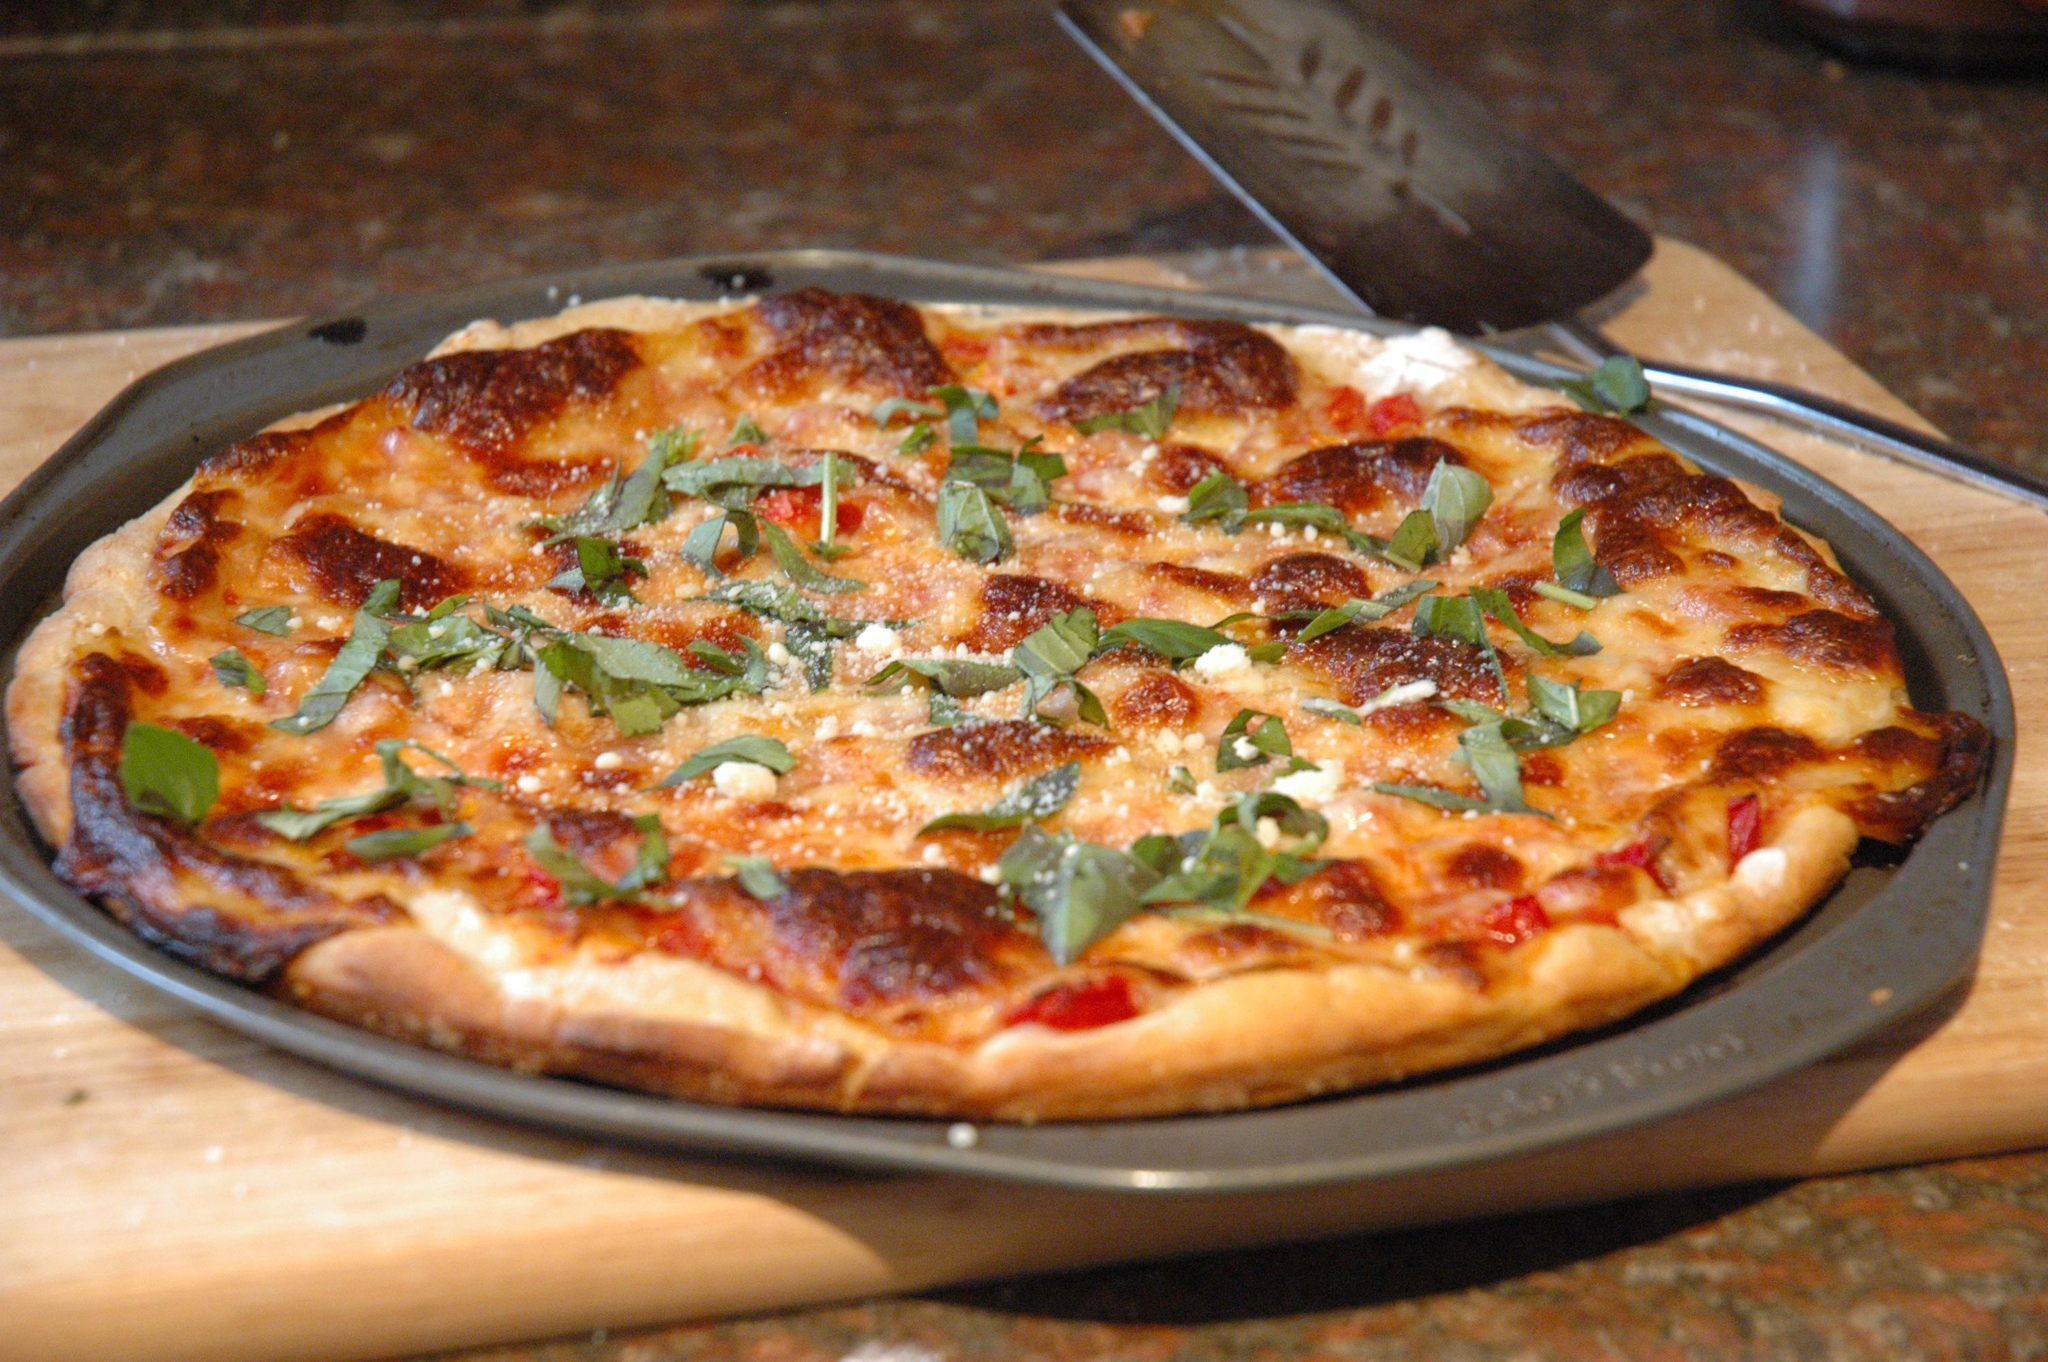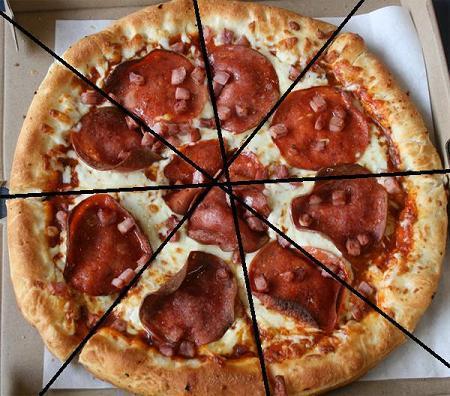The first image is the image on the left, the second image is the image on the right. Given the left and right images, does the statement "Each image shows a full round pizza." hold true? Answer yes or no. Yes. The first image is the image on the left, the second image is the image on the right. For the images displayed, is the sentence "One of the pizzas has no other toppings but cheese." factually correct? Answer yes or no. No. 